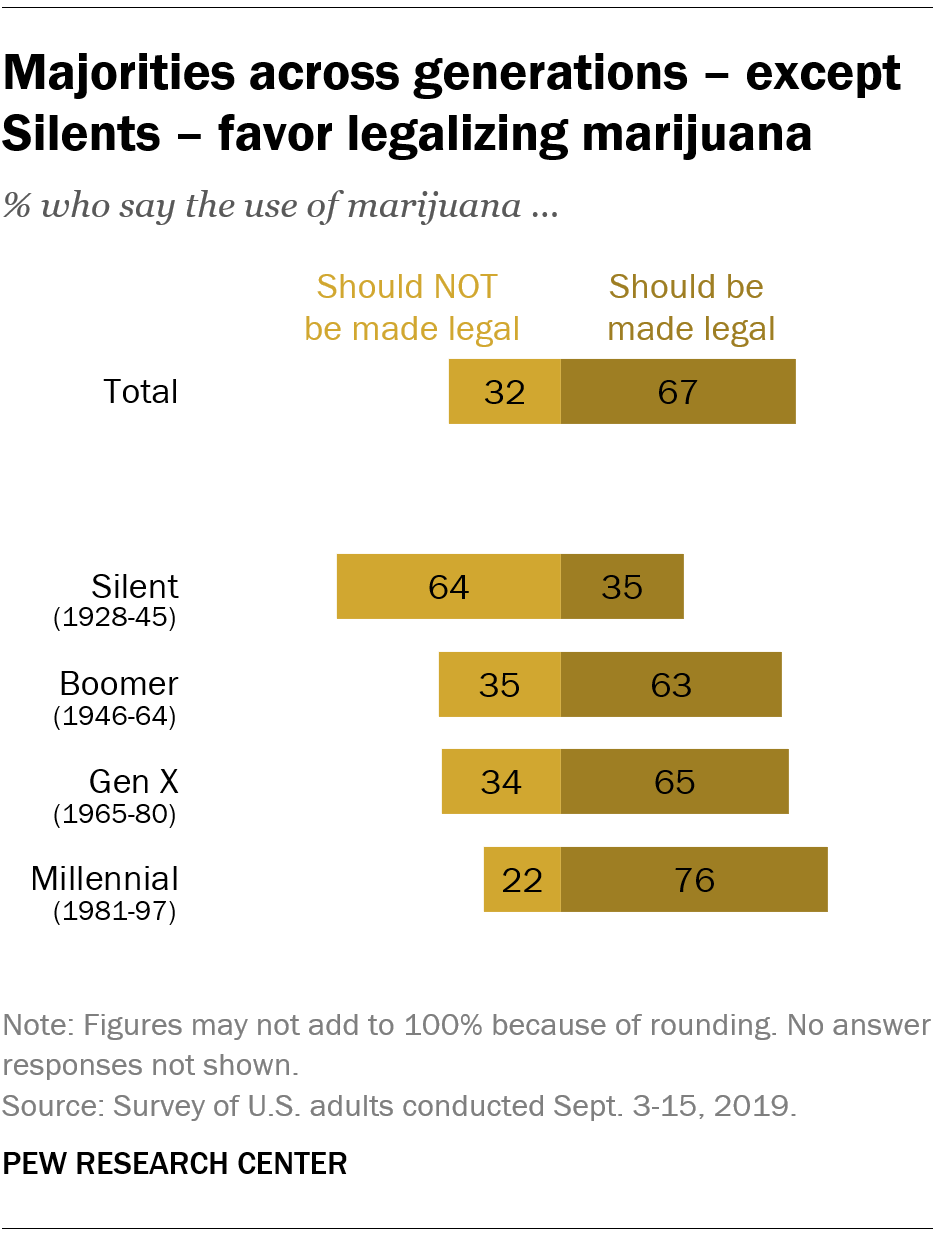Draw attention to some important aspects in this diagram. According to a recent survey, only 0.35% of the total US population favors the legalization of marijuana, while 99.65% of the population opposes it. According to a survey of Boomers, a majority, 0.63, favor the legalization of marijuana. 